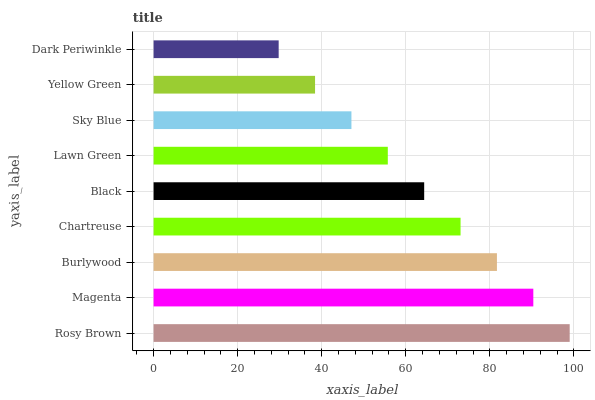Is Dark Periwinkle the minimum?
Answer yes or no. Yes. Is Rosy Brown the maximum?
Answer yes or no. Yes. Is Magenta the minimum?
Answer yes or no. No. Is Magenta the maximum?
Answer yes or no. No. Is Rosy Brown greater than Magenta?
Answer yes or no. Yes. Is Magenta less than Rosy Brown?
Answer yes or no. Yes. Is Magenta greater than Rosy Brown?
Answer yes or no. No. Is Rosy Brown less than Magenta?
Answer yes or no. No. Is Black the high median?
Answer yes or no. Yes. Is Black the low median?
Answer yes or no. Yes. Is Lawn Green the high median?
Answer yes or no. No. Is Chartreuse the low median?
Answer yes or no. No. 